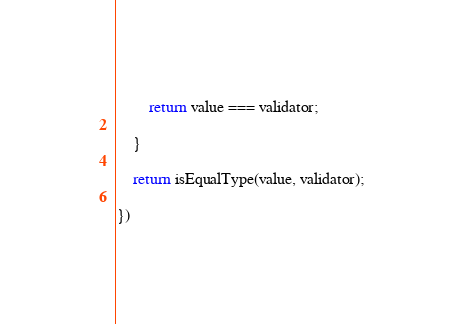<code> <loc_0><loc_0><loc_500><loc_500><_JavaScript_>
        return value === validator;

    }

    return isEqualType(value, validator);

})</code> 